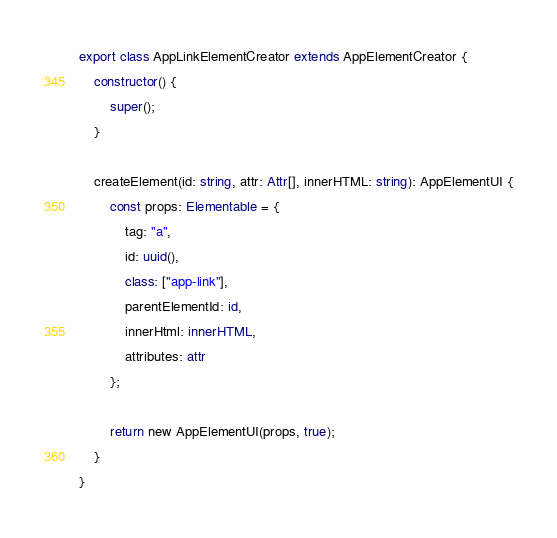Convert code to text. <code><loc_0><loc_0><loc_500><loc_500><_TypeScript_>
export class AppLinkElementCreator extends AppElementCreator {
    constructor() {
        super();
    }
    
    createElement(id: string, attr: Attr[], innerHTML: string): AppElementUI {
        const props: Elementable = {
            tag: "a",
            id: uuid(), 
            class: ["app-link"],
            parentElementId: id,
            innerHtml: innerHTML,
            attributes: attr
        };

        return new AppElementUI(props, true);
    }
}</code> 